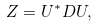Convert formula to latex. <formula><loc_0><loc_0><loc_500><loc_500>Z = U ^ { * } D U ,</formula> 